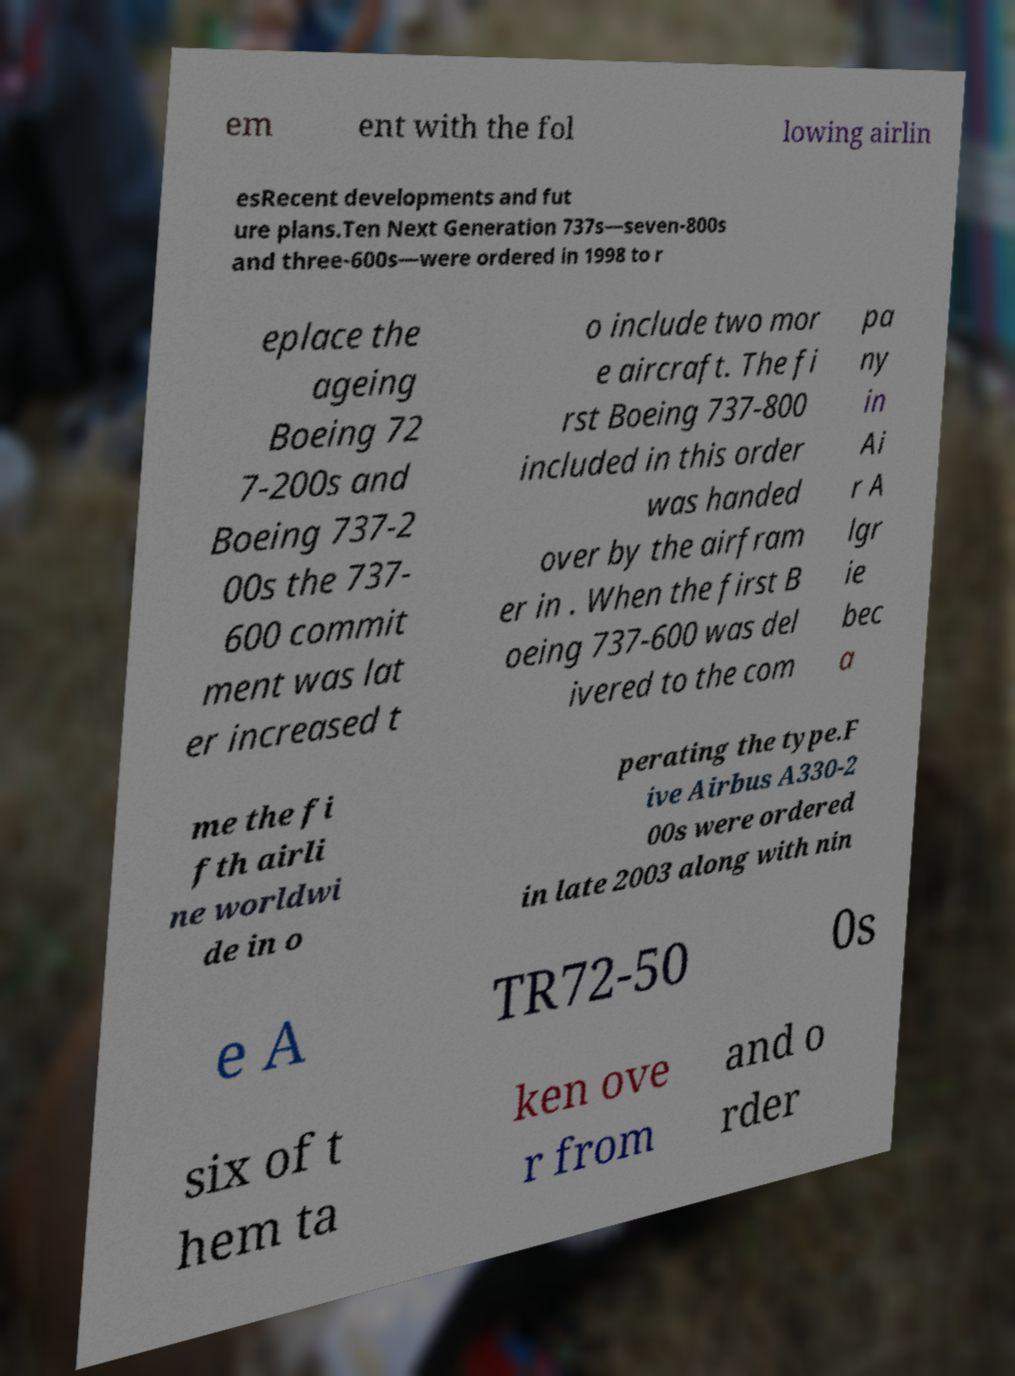Could you extract and type out the text from this image? em ent with the fol lowing airlin esRecent developments and fut ure plans.Ten Next Generation 737s—seven-800s and three-600s—were ordered in 1998 to r eplace the ageing Boeing 72 7-200s and Boeing 737-2 00s the 737- 600 commit ment was lat er increased t o include two mor e aircraft. The fi rst Boeing 737-800 included in this order was handed over by the airfram er in . When the first B oeing 737-600 was del ivered to the com pa ny in Ai r A lgr ie bec a me the fi fth airli ne worldwi de in o perating the type.F ive Airbus A330-2 00s were ordered in late 2003 along with nin e A TR72-50 0s six of t hem ta ken ove r from and o rder 